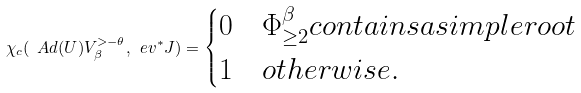Convert formula to latex. <formula><loc_0><loc_0><loc_500><loc_500>\chi _ { c } ( \ A d ( U ) V ^ { > - \theta } _ { \beta } , \ e v ^ { * } J ) = \begin{cases} 0 & \Phi ^ { \beta } _ { \geq 2 } c o n t a i n s a s i m p l e r o o t \\ 1 & o t h e r w i s e . \end{cases}</formula> 